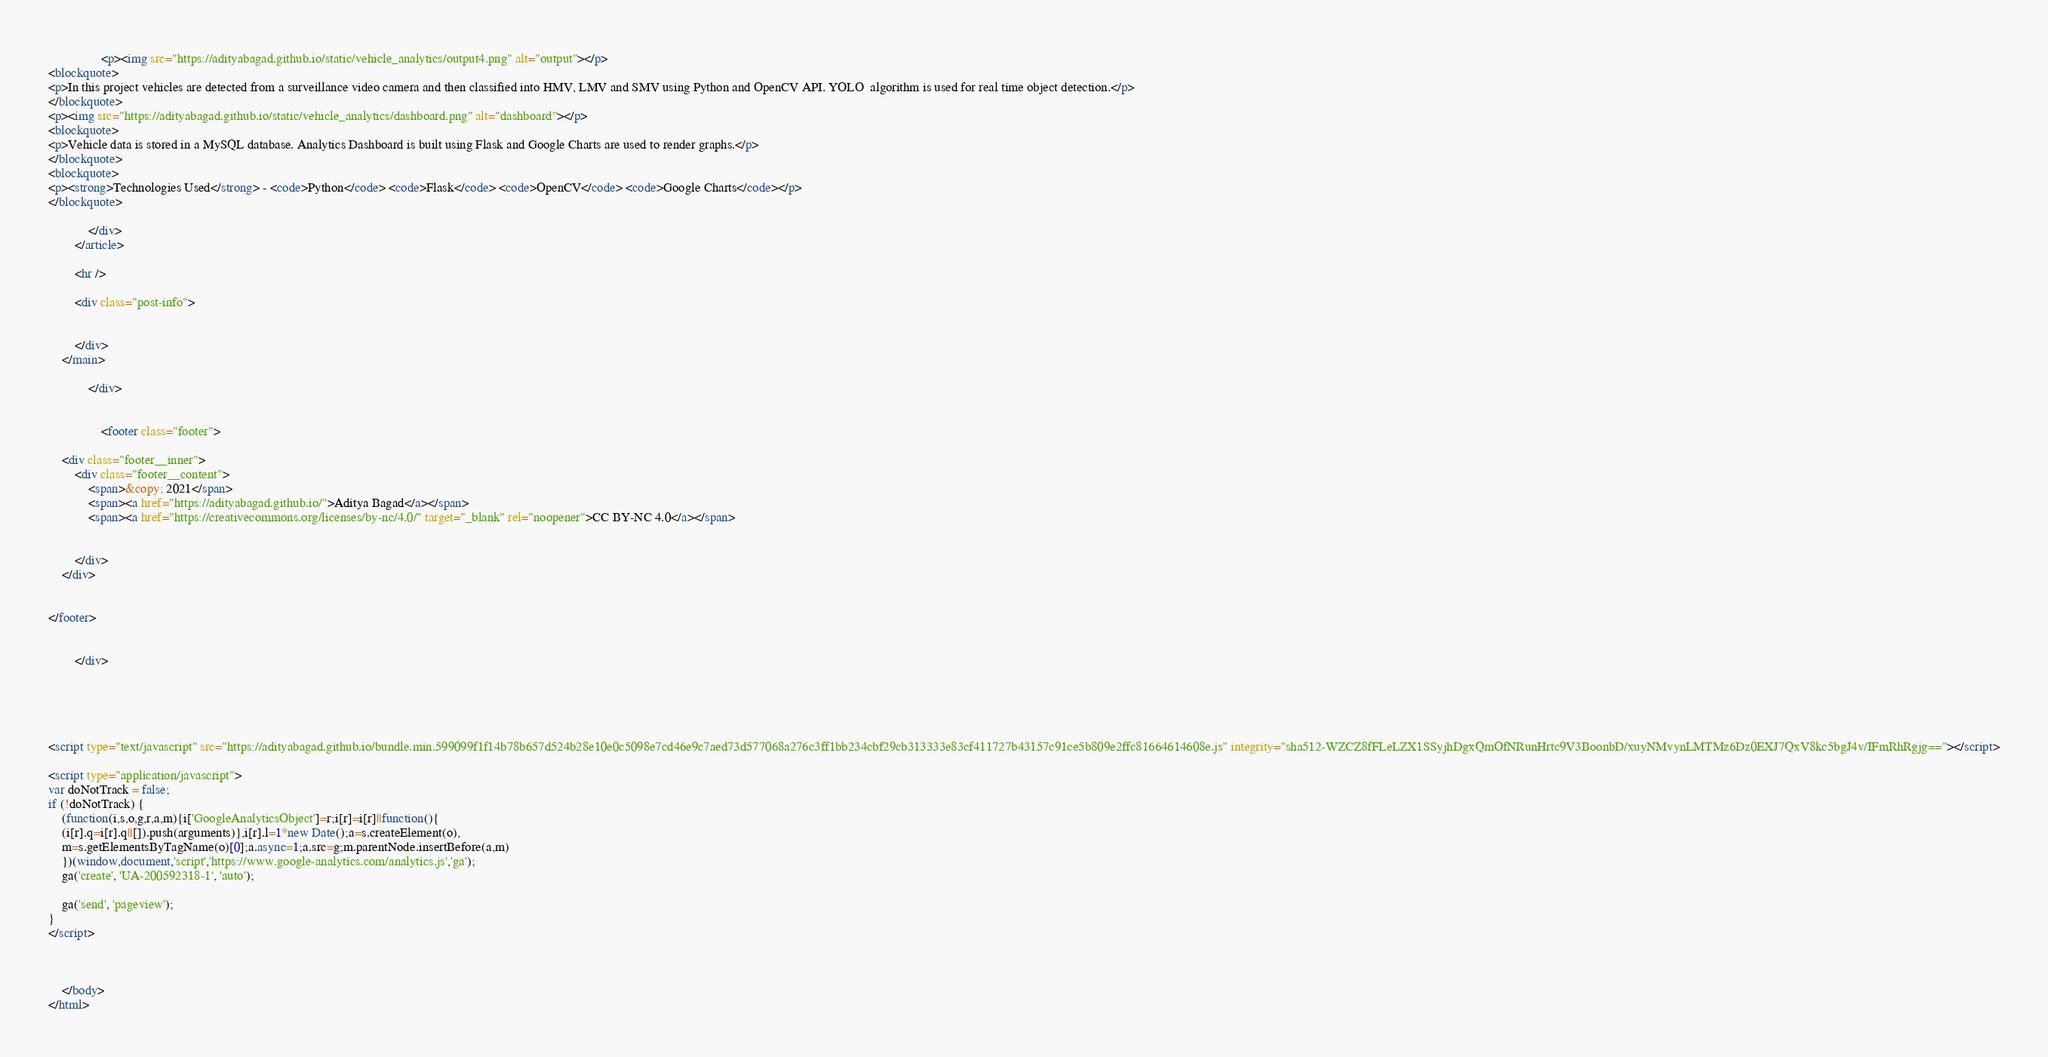Convert code to text. <code><loc_0><loc_0><loc_500><loc_500><_HTML_>                <p><img src="https://adityabagad.github.io/static/vehicle_analytics/output4.png" alt="output"></p>
<blockquote>
<p>In this project vehicles are detected from a surveillance video camera and then classified into HMV, LMV and SMV using Python and OpenCV API. YOLO  algorithm is used for real time object detection.</p>
</blockquote>
<p><img src="https://adityabagad.github.io/static/vehicle_analytics/dashboard.png" alt="dashboard"></p>
<blockquote>
<p>Vehicle data is stored in a MySQL database. Analytics Dashboard is built using Flask and Google Charts are used to render graphs.</p>
</blockquote>
<blockquote>
<p><strong>Technologies Used</strong> - <code>Python</code> <code>Flask</code> <code>OpenCV</code> <code>Google Charts</code></p>
</blockquote>

            </div>
        </article>

        <hr />

        <div class="post-info">
            
            
  		</div>
    </main>

            </div>

            
                <footer class="footer">
    
    <div class="footer__inner">
        <div class="footer__content">
            <span>&copy; 2021</span>
            <span><a href="https://adityabagad.github.io/">Aditya Bagad</a></span>
            <span><a href="https://creativecommons.org/licenses/by-nc/4.0/" target="_blank" rel="noopener">CC BY-NC 4.0</a></span>
            
            
        </div>
    </div>
    
    
</footer>

            
        </div>

        



<script type="text/javascript" src="https://adityabagad.github.io/bundle.min.599099f1f14b78b657d524b28e10e0c5098e7cd46e9c7aed73d577068a276c3ff1bb234cbf29cb313333e83cf411727b43157c91ce5b809e2ffc81664614608e.js" integrity="sha512-WZCZ8fFLeLZX1SSyjhDgxQmOfNRunHrtc9V3BoonbD/xuyNMvynLMTMz6Dz0EXJ7QxV8kc5bgJ4v/IFmRhRgjg=="></script>
    
<script type="application/javascript">
var doNotTrack = false;
if (!doNotTrack) {
	(function(i,s,o,g,r,a,m){i['GoogleAnalyticsObject']=r;i[r]=i[r]||function(){
	(i[r].q=i[r].q||[]).push(arguments)},i[r].l=1*new Date();a=s.createElement(o),
	m=s.getElementsByTagName(o)[0];a.async=1;a.src=g;m.parentNode.insertBefore(a,m)
	})(window,document,'script','https://www.google-analytics.com/analytics.js','ga');
	ga('create', 'UA-200592318-1', 'auto');
	
	ga('send', 'pageview');
}
</script>



    </body>
</html>
</code> 